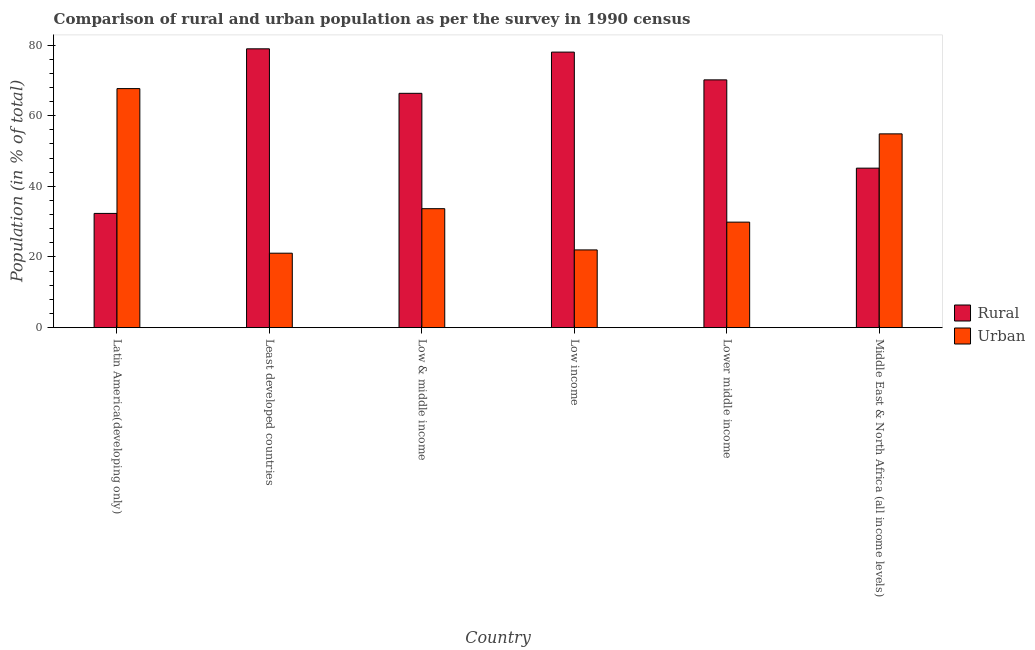How many different coloured bars are there?
Ensure brevity in your answer.  2. How many groups of bars are there?
Your answer should be compact. 6. Are the number of bars per tick equal to the number of legend labels?
Give a very brief answer. Yes. How many bars are there on the 1st tick from the left?
Offer a terse response. 2. How many bars are there on the 6th tick from the right?
Provide a succinct answer. 2. What is the label of the 4th group of bars from the left?
Give a very brief answer. Low income. In how many cases, is the number of bars for a given country not equal to the number of legend labels?
Your response must be concise. 0. What is the urban population in Low & middle income?
Ensure brevity in your answer.  33.68. Across all countries, what is the maximum rural population?
Your response must be concise. 78.92. Across all countries, what is the minimum rural population?
Offer a very short reply. 32.34. In which country was the rural population maximum?
Offer a terse response. Least developed countries. In which country was the urban population minimum?
Provide a short and direct response. Least developed countries. What is the total rural population in the graph?
Provide a short and direct response. 370.86. What is the difference between the rural population in Latin America(developing only) and that in Lower middle income?
Your response must be concise. -37.8. What is the difference between the urban population in Lower middle income and the rural population in Middle East & North Africa (all income levels)?
Offer a terse response. -15.28. What is the average urban population per country?
Ensure brevity in your answer.  38.19. What is the difference between the urban population and rural population in Least developed countries?
Make the answer very short. -57.84. What is the ratio of the urban population in Low income to that in Middle East & North Africa (all income levels)?
Ensure brevity in your answer.  0.4. What is the difference between the highest and the second highest rural population?
Offer a very short reply. 0.93. What is the difference between the highest and the lowest urban population?
Make the answer very short. 46.58. Is the sum of the urban population in Low income and Middle East & North Africa (all income levels) greater than the maximum rural population across all countries?
Your answer should be very brief. No. What does the 2nd bar from the left in Middle East & North Africa (all income levels) represents?
Ensure brevity in your answer.  Urban. What does the 1st bar from the right in Lower middle income represents?
Ensure brevity in your answer.  Urban. How many countries are there in the graph?
Give a very brief answer. 6. Are the values on the major ticks of Y-axis written in scientific E-notation?
Your answer should be compact. No. How many legend labels are there?
Your answer should be compact. 2. How are the legend labels stacked?
Provide a short and direct response. Vertical. What is the title of the graph?
Offer a terse response. Comparison of rural and urban population as per the survey in 1990 census. What is the label or title of the X-axis?
Make the answer very short. Country. What is the label or title of the Y-axis?
Your answer should be compact. Population (in % of total). What is the Population (in % of total) of Rural in Latin America(developing only)?
Make the answer very short. 32.34. What is the Population (in % of total) of Urban in Latin America(developing only)?
Keep it short and to the point. 67.66. What is the Population (in % of total) of Rural in Least developed countries?
Offer a very short reply. 78.92. What is the Population (in % of total) of Urban in Least developed countries?
Offer a terse response. 21.08. What is the Population (in % of total) in Rural in Low & middle income?
Offer a terse response. 66.32. What is the Population (in % of total) in Urban in Low & middle income?
Ensure brevity in your answer.  33.68. What is the Population (in % of total) of Rural in Low income?
Your answer should be compact. 77.99. What is the Population (in % of total) of Urban in Low income?
Offer a terse response. 22.01. What is the Population (in % of total) in Rural in Lower middle income?
Give a very brief answer. 70.13. What is the Population (in % of total) in Urban in Lower middle income?
Your answer should be compact. 29.87. What is the Population (in % of total) of Rural in Middle East & North Africa (all income levels)?
Give a very brief answer. 45.15. What is the Population (in % of total) of Urban in Middle East & North Africa (all income levels)?
Make the answer very short. 54.85. Across all countries, what is the maximum Population (in % of total) in Rural?
Offer a terse response. 78.92. Across all countries, what is the maximum Population (in % of total) in Urban?
Your answer should be compact. 67.66. Across all countries, what is the minimum Population (in % of total) of Rural?
Offer a terse response. 32.34. Across all countries, what is the minimum Population (in % of total) of Urban?
Your answer should be very brief. 21.08. What is the total Population (in % of total) in Rural in the graph?
Make the answer very short. 370.86. What is the total Population (in % of total) of Urban in the graph?
Your response must be concise. 229.14. What is the difference between the Population (in % of total) of Rural in Latin America(developing only) and that in Least developed countries?
Offer a terse response. -46.58. What is the difference between the Population (in % of total) in Urban in Latin America(developing only) and that in Least developed countries?
Provide a short and direct response. 46.58. What is the difference between the Population (in % of total) of Rural in Latin America(developing only) and that in Low & middle income?
Ensure brevity in your answer.  -33.99. What is the difference between the Population (in % of total) in Urban in Latin America(developing only) and that in Low & middle income?
Give a very brief answer. 33.99. What is the difference between the Population (in % of total) of Rural in Latin America(developing only) and that in Low income?
Provide a short and direct response. -45.66. What is the difference between the Population (in % of total) in Urban in Latin America(developing only) and that in Low income?
Provide a short and direct response. 45.66. What is the difference between the Population (in % of total) in Rural in Latin America(developing only) and that in Lower middle income?
Offer a terse response. -37.8. What is the difference between the Population (in % of total) of Urban in Latin America(developing only) and that in Lower middle income?
Offer a very short reply. 37.8. What is the difference between the Population (in % of total) in Rural in Latin America(developing only) and that in Middle East & North Africa (all income levels)?
Ensure brevity in your answer.  -12.81. What is the difference between the Population (in % of total) in Urban in Latin America(developing only) and that in Middle East & North Africa (all income levels)?
Offer a terse response. 12.81. What is the difference between the Population (in % of total) in Rural in Least developed countries and that in Low & middle income?
Offer a very short reply. 12.6. What is the difference between the Population (in % of total) in Urban in Least developed countries and that in Low & middle income?
Offer a terse response. -12.6. What is the difference between the Population (in % of total) in Rural in Least developed countries and that in Low income?
Ensure brevity in your answer.  0.93. What is the difference between the Population (in % of total) of Urban in Least developed countries and that in Low income?
Your answer should be very brief. -0.93. What is the difference between the Population (in % of total) in Rural in Least developed countries and that in Lower middle income?
Offer a terse response. 8.79. What is the difference between the Population (in % of total) of Urban in Least developed countries and that in Lower middle income?
Keep it short and to the point. -8.79. What is the difference between the Population (in % of total) of Rural in Least developed countries and that in Middle East & North Africa (all income levels)?
Offer a very short reply. 33.77. What is the difference between the Population (in % of total) in Urban in Least developed countries and that in Middle East & North Africa (all income levels)?
Make the answer very short. -33.77. What is the difference between the Population (in % of total) in Rural in Low & middle income and that in Low income?
Your response must be concise. -11.67. What is the difference between the Population (in % of total) of Urban in Low & middle income and that in Low income?
Ensure brevity in your answer.  11.67. What is the difference between the Population (in % of total) in Rural in Low & middle income and that in Lower middle income?
Ensure brevity in your answer.  -3.81. What is the difference between the Population (in % of total) of Urban in Low & middle income and that in Lower middle income?
Your response must be concise. 3.81. What is the difference between the Population (in % of total) of Rural in Low & middle income and that in Middle East & North Africa (all income levels)?
Give a very brief answer. 21.18. What is the difference between the Population (in % of total) in Urban in Low & middle income and that in Middle East & North Africa (all income levels)?
Your response must be concise. -21.18. What is the difference between the Population (in % of total) in Rural in Low income and that in Lower middle income?
Your answer should be very brief. 7.86. What is the difference between the Population (in % of total) in Urban in Low income and that in Lower middle income?
Offer a very short reply. -7.86. What is the difference between the Population (in % of total) of Rural in Low income and that in Middle East & North Africa (all income levels)?
Give a very brief answer. 32.84. What is the difference between the Population (in % of total) in Urban in Low income and that in Middle East & North Africa (all income levels)?
Make the answer very short. -32.84. What is the difference between the Population (in % of total) in Rural in Lower middle income and that in Middle East & North Africa (all income levels)?
Keep it short and to the point. 24.98. What is the difference between the Population (in % of total) of Urban in Lower middle income and that in Middle East & North Africa (all income levels)?
Keep it short and to the point. -24.98. What is the difference between the Population (in % of total) in Rural in Latin America(developing only) and the Population (in % of total) in Urban in Least developed countries?
Keep it short and to the point. 11.26. What is the difference between the Population (in % of total) in Rural in Latin America(developing only) and the Population (in % of total) in Urban in Low & middle income?
Ensure brevity in your answer.  -1.34. What is the difference between the Population (in % of total) of Rural in Latin America(developing only) and the Population (in % of total) of Urban in Low income?
Provide a short and direct response. 10.33. What is the difference between the Population (in % of total) in Rural in Latin America(developing only) and the Population (in % of total) in Urban in Lower middle income?
Keep it short and to the point. 2.47. What is the difference between the Population (in % of total) of Rural in Latin America(developing only) and the Population (in % of total) of Urban in Middle East & North Africa (all income levels)?
Provide a short and direct response. -22.51. What is the difference between the Population (in % of total) of Rural in Least developed countries and the Population (in % of total) of Urban in Low & middle income?
Offer a terse response. 45.25. What is the difference between the Population (in % of total) of Rural in Least developed countries and the Population (in % of total) of Urban in Low income?
Make the answer very short. 56.91. What is the difference between the Population (in % of total) of Rural in Least developed countries and the Population (in % of total) of Urban in Lower middle income?
Ensure brevity in your answer.  49.05. What is the difference between the Population (in % of total) in Rural in Least developed countries and the Population (in % of total) in Urban in Middle East & North Africa (all income levels)?
Give a very brief answer. 24.07. What is the difference between the Population (in % of total) in Rural in Low & middle income and the Population (in % of total) in Urban in Low income?
Your response must be concise. 44.32. What is the difference between the Population (in % of total) of Rural in Low & middle income and the Population (in % of total) of Urban in Lower middle income?
Your response must be concise. 36.46. What is the difference between the Population (in % of total) of Rural in Low & middle income and the Population (in % of total) of Urban in Middle East & North Africa (all income levels)?
Ensure brevity in your answer.  11.47. What is the difference between the Population (in % of total) of Rural in Low income and the Population (in % of total) of Urban in Lower middle income?
Give a very brief answer. 48.13. What is the difference between the Population (in % of total) in Rural in Low income and the Population (in % of total) in Urban in Middle East & North Africa (all income levels)?
Keep it short and to the point. 23.14. What is the difference between the Population (in % of total) of Rural in Lower middle income and the Population (in % of total) of Urban in Middle East & North Africa (all income levels)?
Give a very brief answer. 15.28. What is the average Population (in % of total) in Rural per country?
Give a very brief answer. 61.81. What is the average Population (in % of total) of Urban per country?
Ensure brevity in your answer.  38.19. What is the difference between the Population (in % of total) of Rural and Population (in % of total) of Urban in Latin America(developing only)?
Provide a succinct answer. -35.33. What is the difference between the Population (in % of total) of Rural and Population (in % of total) of Urban in Least developed countries?
Your response must be concise. 57.84. What is the difference between the Population (in % of total) of Rural and Population (in % of total) of Urban in Low & middle income?
Make the answer very short. 32.65. What is the difference between the Population (in % of total) of Rural and Population (in % of total) of Urban in Low income?
Your response must be concise. 55.99. What is the difference between the Population (in % of total) of Rural and Population (in % of total) of Urban in Lower middle income?
Make the answer very short. 40.27. What is the difference between the Population (in % of total) in Rural and Population (in % of total) in Urban in Middle East & North Africa (all income levels)?
Give a very brief answer. -9.7. What is the ratio of the Population (in % of total) in Rural in Latin America(developing only) to that in Least developed countries?
Offer a terse response. 0.41. What is the ratio of the Population (in % of total) of Urban in Latin America(developing only) to that in Least developed countries?
Offer a terse response. 3.21. What is the ratio of the Population (in % of total) in Rural in Latin America(developing only) to that in Low & middle income?
Your answer should be very brief. 0.49. What is the ratio of the Population (in % of total) of Urban in Latin America(developing only) to that in Low & middle income?
Offer a very short reply. 2.01. What is the ratio of the Population (in % of total) in Rural in Latin America(developing only) to that in Low income?
Ensure brevity in your answer.  0.41. What is the ratio of the Population (in % of total) of Urban in Latin America(developing only) to that in Low income?
Your answer should be compact. 3.07. What is the ratio of the Population (in % of total) in Rural in Latin America(developing only) to that in Lower middle income?
Your answer should be compact. 0.46. What is the ratio of the Population (in % of total) in Urban in Latin America(developing only) to that in Lower middle income?
Ensure brevity in your answer.  2.27. What is the ratio of the Population (in % of total) in Rural in Latin America(developing only) to that in Middle East & North Africa (all income levels)?
Provide a succinct answer. 0.72. What is the ratio of the Population (in % of total) in Urban in Latin America(developing only) to that in Middle East & North Africa (all income levels)?
Your response must be concise. 1.23. What is the ratio of the Population (in % of total) of Rural in Least developed countries to that in Low & middle income?
Keep it short and to the point. 1.19. What is the ratio of the Population (in % of total) in Urban in Least developed countries to that in Low & middle income?
Give a very brief answer. 0.63. What is the ratio of the Population (in % of total) of Rural in Least developed countries to that in Low income?
Ensure brevity in your answer.  1.01. What is the ratio of the Population (in % of total) in Urban in Least developed countries to that in Low income?
Give a very brief answer. 0.96. What is the ratio of the Population (in % of total) in Rural in Least developed countries to that in Lower middle income?
Offer a very short reply. 1.13. What is the ratio of the Population (in % of total) in Urban in Least developed countries to that in Lower middle income?
Your response must be concise. 0.71. What is the ratio of the Population (in % of total) of Rural in Least developed countries to that in Middle East & North Africa (all income levels)?
Ensure brevity in your answer.  1.75. What is the ratio of the Population (in % of total) in Urban in Least developed countries to that in Middle East & North Africa (all income levels)?
Give a very brief answer. 0.38. What is the ratio of the Population (in % of total) of Rural in Low & middle income to that in Low income?
Offer a very short reply. 0.85. What is the ratio of the Population (in % of total) in Urban in Low & middle income to that in Low income?
Provide a succinct answer. 1.53. What is the ratio of the Population (in % of total) in Rural in Low & middle income to that in Lower middle income?
Give a very brief answer. 0.95. What is the ratio of the Population (in % of total) in Urban in Low & middle income to that in Lower middle income?
Make the answer very short. 1.13. What is the ratio of the Population (in % of total) in Rural in Low & middle income to that in Middle East & North Africa (all income levels)?
Provide a short and direct response. 1.47. What is the ratio of the Population (in % of total) of Urban in Low & middle income to that in Middle East & North Africa (all income levels)?
Make the answer very short. 0.61. What is the ratio of the Population (in % of total) of Rural in Low income to that in Lower middle income?
Provide a succinct answer. 1.11. What is the ratio of the Population (in % of total) of Urban in Low income to that in Lower middle income?
Keep it short and to the point. 0.74. What is the ratio of the Population (in % of total) in Rural in Low income to that in Middle East & North Africa (all income levels)?
Offer a very short reply. 1.73. What is the ratio of the Population (in % of total) in Urban in Low income to that in Middle East & North Africa (all income levels)?
Give a very brief answer. 0.4. What is the ratio of the Population (in % of total) of Rural in Lower middle income to that in Middle East & North Africa (all income levels)?
Provide a succinct answer. 1.55. What is the ratio of the Population (in % of total) of Urban in Lower middle income to that in Middle East & North Africa (all income levels)?
Provide a short and direct response. 0.54. What is the difference between the highest and the second highest Population (in % of total) in Rural?
Your answer should be compact. 0.93. What is the difference between the highest and the second highest Population (in % of total) in Urban?
Provide a short and direct response. 12.81. What is the difference between the highest and the lowest Population (in % of total) in Rural?
Ensure brevity in your answer.  46.58. What is the difference between the highest and the lowest Population (in % of total) of Urban?
Your response must be concise. 46.58. 